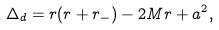Convert formula to latex. <formula><loc_0><loc_0><loc_500><loc_500>\Delta _ { d } = r ( r + r _ { - } ) - 2 M r + a ^ { 2 } ,</formula> 